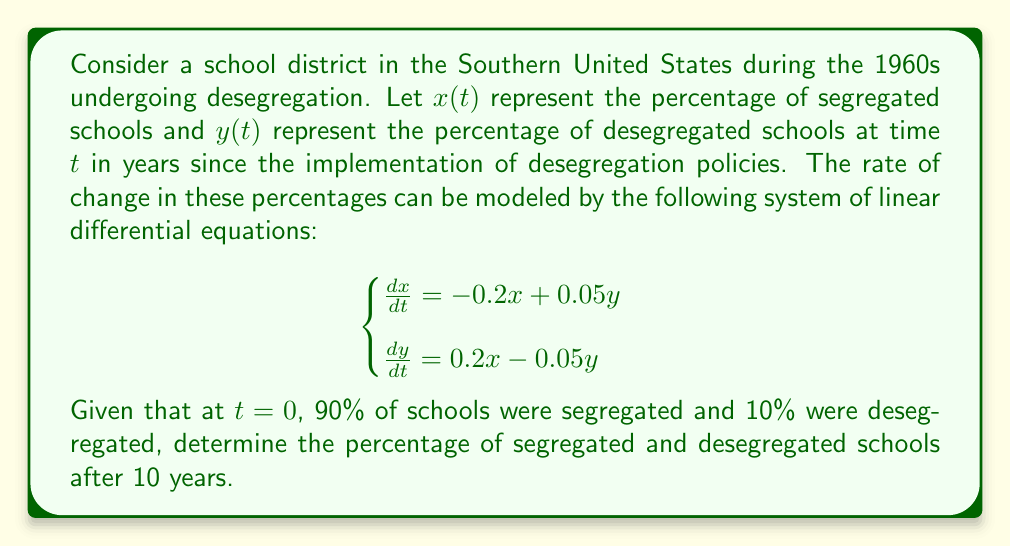What is the answer to this math problem? To solve this system of linear differential equations, we'll follow these steps:

1) First, we need to find the eigenvalues and eigenvectors of the coefficient matrix:

   $$A = \begin{bmatrix} -0.2 & 0.05 \\ 0.2 & -0.05 \end{bmatrix}$$

2) The characteristic equation is:
   
   $$\det(A - \lambda I) = \begin{vmatrix} -0.2-\lambda & 0.05 \\ 0.2 & -0.05-\lambda \end{vmatrix} = \lambda^2 + 0.25\lambda = 0$$

3) Solving this equation gives us the eigenvalues:
   
   $\lambda_1 = 0$ and $\lambda_2 = -0.25$

4) For $\lambda_1 = 0$, the eigenvector $v_1$ satisfies:
   
   $$\begin{bmatrix} -0.2 & 0.05 \\ 0.2 & -0.05 \end{bmatrix} \begin{bmatrix} v_1 \\ v_2 \end{bmatrix} = \begin{bmatrix} 0 \\ 0 \end{bmatrix}$$

   This gives us $v_1 = \begin{bmatrix} 1 \\ 4 \end{bmatrix}$

5) For $\lambda_2 = -0.25$, the eigenvector $v_2$ satisfies:
   
   $$\begin{bmatrix} 0.05 & 0.05 \\ 0.2 & 0.2 \end{bmatrix} \begin{bmatrix} v_1 \\ v_2 \end{bmatrix} = \begin{bmatrix} 0 \\ 0 \end{bmatrix}$$

   This gives us $v_2 = \begin{bmatrix} 1 \\ -1 \end{bmatrix}$

6) The general solution is:

   $$\begin{bmatrix} x(t) \\ y(t) \end{bmatrix} = c_1 \begin{bmatrix} 1 \\ 4 \end{bmatrix} + c_2 e^{-0.25t} \begin{bmatrix} 1 \\ -1 \end{bmatrix}$$

7) Using the initial conditions $x(0) = 0.9$ and $y(0) = 0.1$, we can find $c_1$ and $c_2$:

   $$\begin{cases}
   0.9 = c_1 + c_2 \\
   0.1 = 4c_1 - c_2
   \end{cases}$$

   Solving this system gives us $c_1 = 0.2$ and $c_2 = 0.7$

8) Therefore, the solution is:

   $$\begin{bmatrix} x(t) \\ y(t) \end{bmatrix} = 0.2 \begin{bmatrix} 1 \\ 4 \end{bmatrix} + 0.7 e^{-0.25t} \begin{bmatrix} 1 \\ -1 \end{bmatrix}$$

9) After 10 years, $t = 10$, so:

   $$\begin{bmatrix} x(10) \\ y(10) \end{bmatrix} = 0.2 \begin{bmatrix} 1 \\ 4 \end{bmatrix} + 0.7 e^{-2.5} \begin{bmatrix} 1 \\ -1 \end{bmatrix}$$

10) Calculating this gives us:

    $$\begin{bmatrix} x(10) \\ y(10) \end{bmatrix} \approx \begin{bmatrix} 0.2583 \\ 0.7417 \end{bmatrix}$$
Answer: After 10 years, approximately 25.83% of schools will be segregated and 74.17% will be desegregated. 